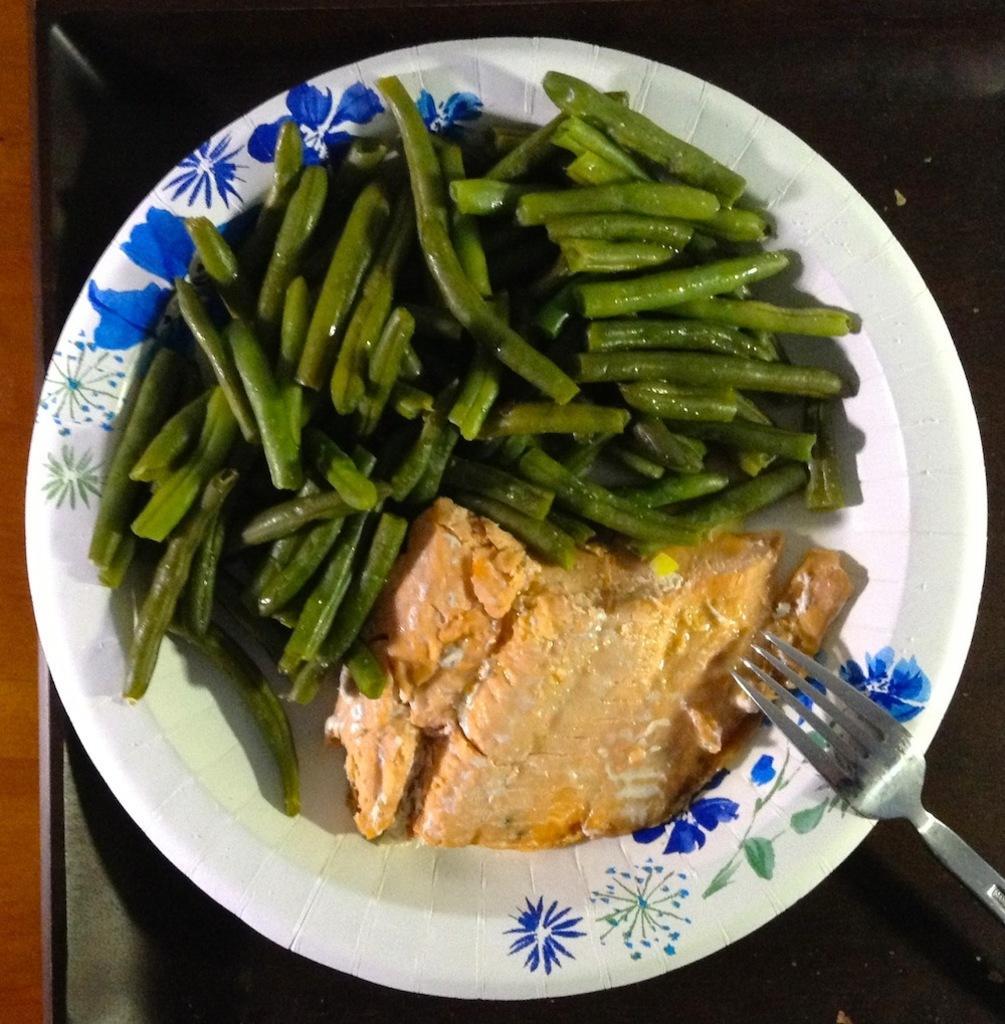Describe this image in one or two sentences. In this image we can see vegetables, bread and fork on plate placed on the table. 